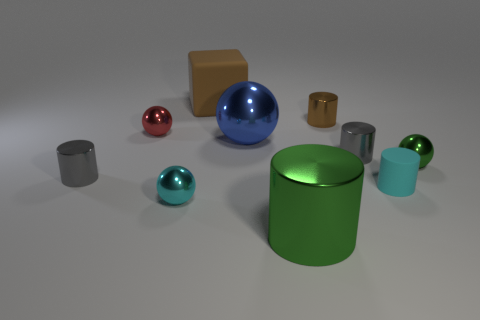How many other objects are there of the same material as the big blue ball?
Your answer should be compact. 7. What number of cylinders are gray matte objects or small gray objects?
Provide a succinct answer. 2. What is the color of the large metallic thing right of the blue metal sphere?
Your answer should be compact. Green. How many shiny objects are small cyan cylinders or large yellow objects?
Provide a succinct answer. 0. There is a small object behind the red metal ball that is on the left side of the large blue object; what is it made of?
Your response must be concise. Metal. There is a cylinder that is the same color as the big matte cube; what is its material?
Keep it short and to the point. Metal. The big ball has what color?
Your answer should be very brief. Blue. Are there any big blue metal things that are to the left of the tiny metal cylinder that is left of the big blue metal thing?
Your answer should be compact. No. What is the big brown object made of?
Your answer should be compact. Rubber. Are the brown thing in front of the cube and the small gray cylinder that is right of the small brown metal cylinder made of the same material?
Offer a terse response. Yes. 